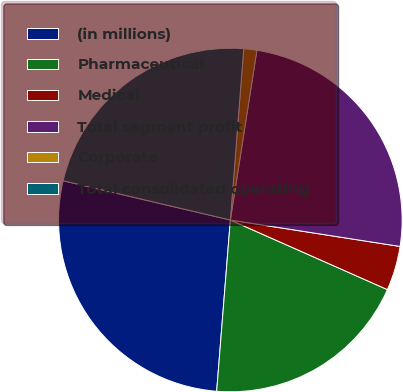<chart> <loc_0><loc_0><loc_500><loc_500><pie_chart><fcel>(in millions)<fcel>Pharmaceutical<fcel>Medical<fcel>Total segment profit<fcel>Corporate<fcel>Total consolidated operating<nl><fcel>27.4%<fcel>19.63%<fcel>4.18%<fcel>24.99%<fcel>1.23%<fcel>22.57%<nl></chart> 